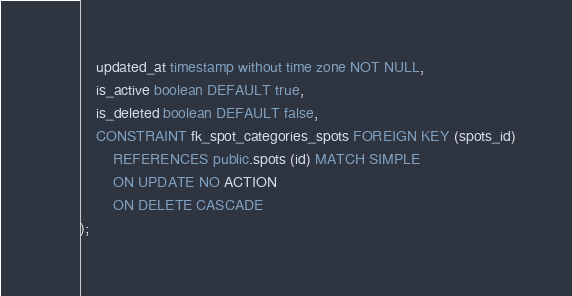Convert code to text. <code><loc_0><loc_0><loc_500><loc_500><_SQL_>    updated_at timestamp without time zone NOT NULL,
    is_active boolean DEFAULT true,
    is_deleted boolean DEFAULT false,
    CONSTRAINT fk_spot_categories_spots FOREIGN KEY (spots_id)
        REFERENCES public.spots (id) MATCH SIMPLE
        ON UPDATE NO ACTION
        ON DELETE CASCADE
);</code> 